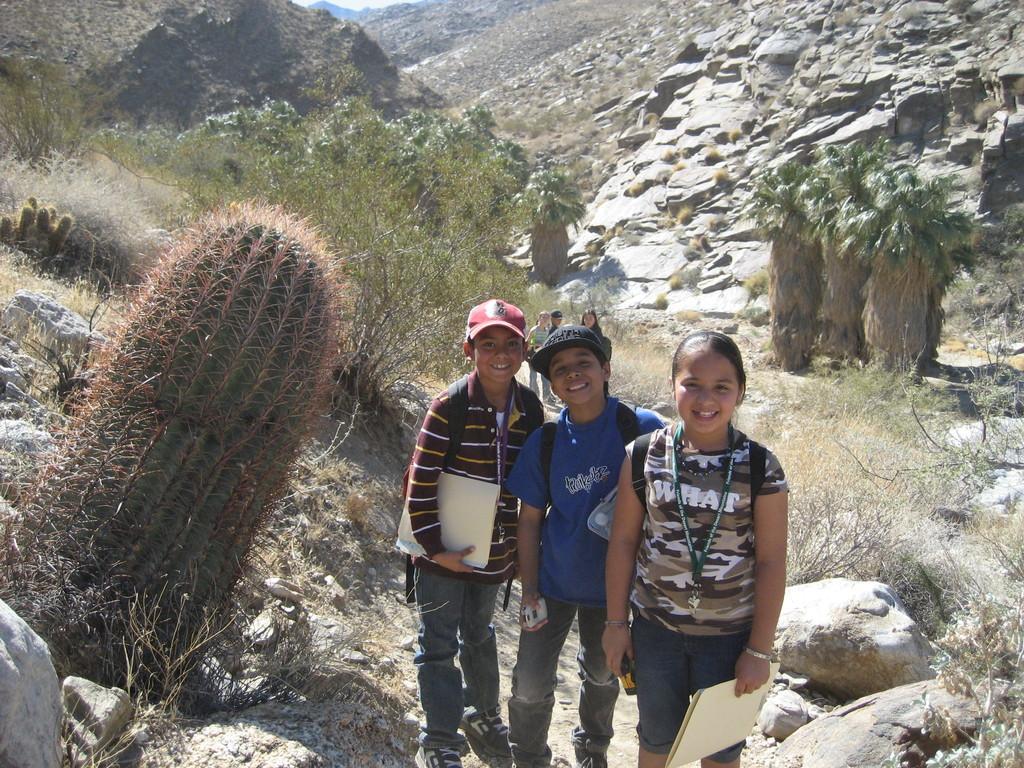Describe this image in one or two sentences. This picture describes about group of people, few are smiling and few people wore caps, beside to them we can see few trees and rocks, in the background we can find hills. 